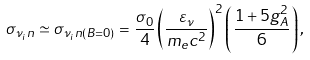<formula> <loc_0><loc_0><loc_500><loc_500>\sigma _ { \nu _ { i } n } \simeq \sigma _ { \nu _ { i } n ( B = 0 ) } = \frac { \sigma _ { 0 } } { 4 } \left ( \frac { \varepsilon _ { \nu } } { m _ { e } c ^ { 2 } } \right ) ^ { 2 } \left ( \frac { 1 + 5 g _ { A } ^ { 2 } } { 6 } \right ) ,</formula> 